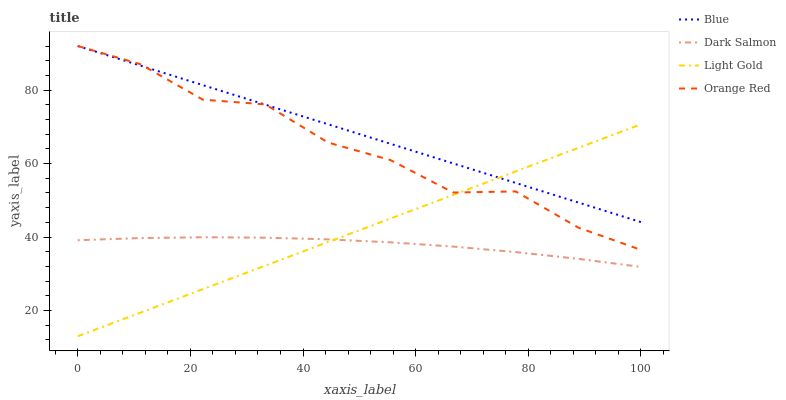Does Dark Salmon have the minimum area under the curve?
Answer yes or no. Yes. Does Blue have the maximum area under the curve?
Answer yes or no. Yes. Does Light Gold have the minimum area under the curve?
Answer yes or no. No. Does Light Gold have the maximum area under the curve?
Answer yes or no. No. Is Light Gold the smoothest?
Answer yes or no. Yes. Is Orange Red the roughest?
Answer yes or no. Yes. Is Dark Salmon the smoothest?
Answer yes or no. No. Is Dark Salmon the roughest?
Answer yes or no. No. Does Dark Salmon have the lowest value?
Answer yes or no. No. Does Orange Red have the highest value?
Answer yes or no. Yes. Does Light Gold have the highest value?
Answer yes or no. No. Is Dark Salmon less than Orange Red?
Answer yes or no. Yes. Is Orange Red greater than Dark Salmon?
Answer yes or no. Yes. Does Orange Red intersect Blue?
Answer yes or no. Yes. Is Orange Red less than Blue?
Answer yes or no. No. Is Orange Red greater than Blue?
Answer yes or no. No. Does Dark Salmon intersect Orange Red?
Answer yes or no. No. 